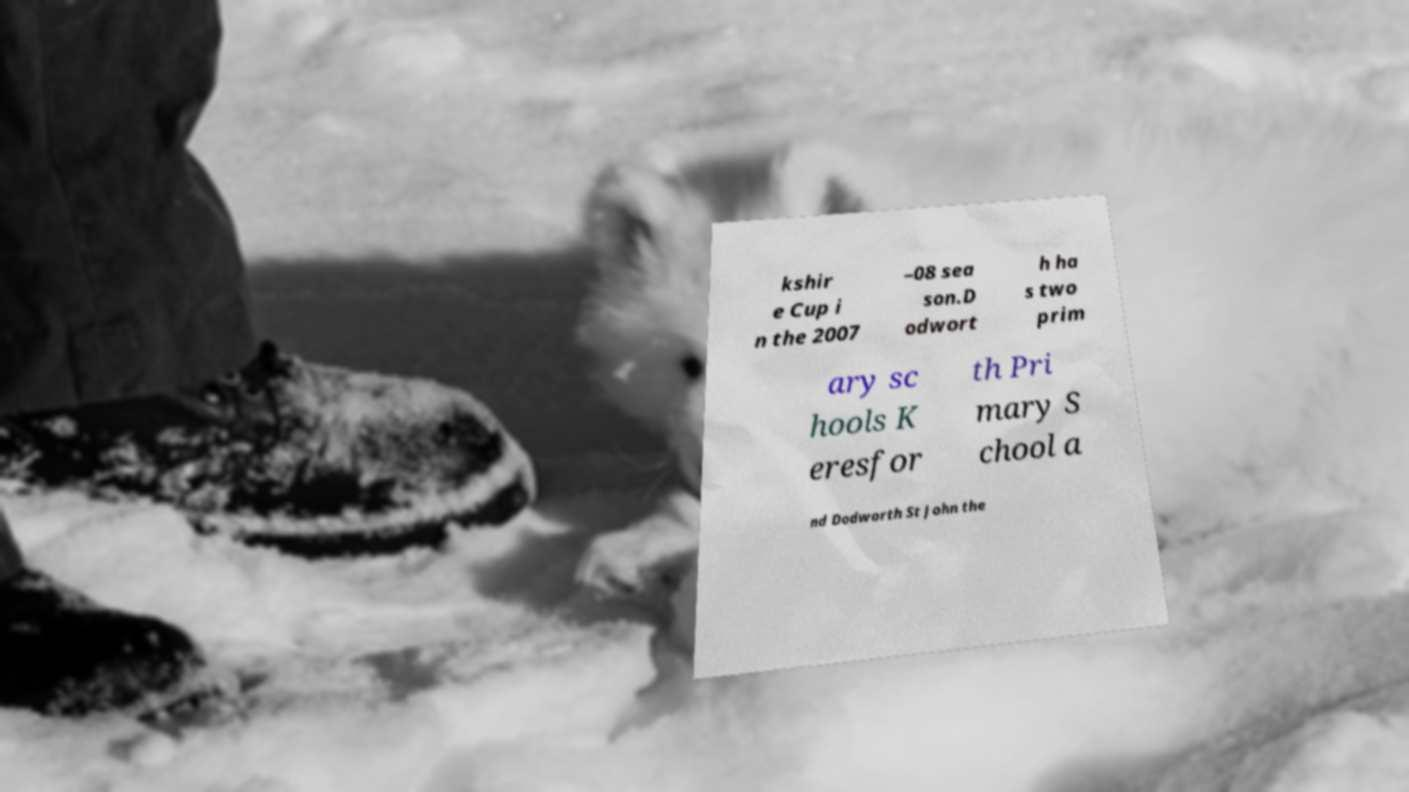Please identify and transcribe the text found in this image. kshir e Cup i n the 2007 –08 sea son.D odwort h ha s two prim ary sc hools K eresfor th Pri mary S chool a nd Dodworth St John the 